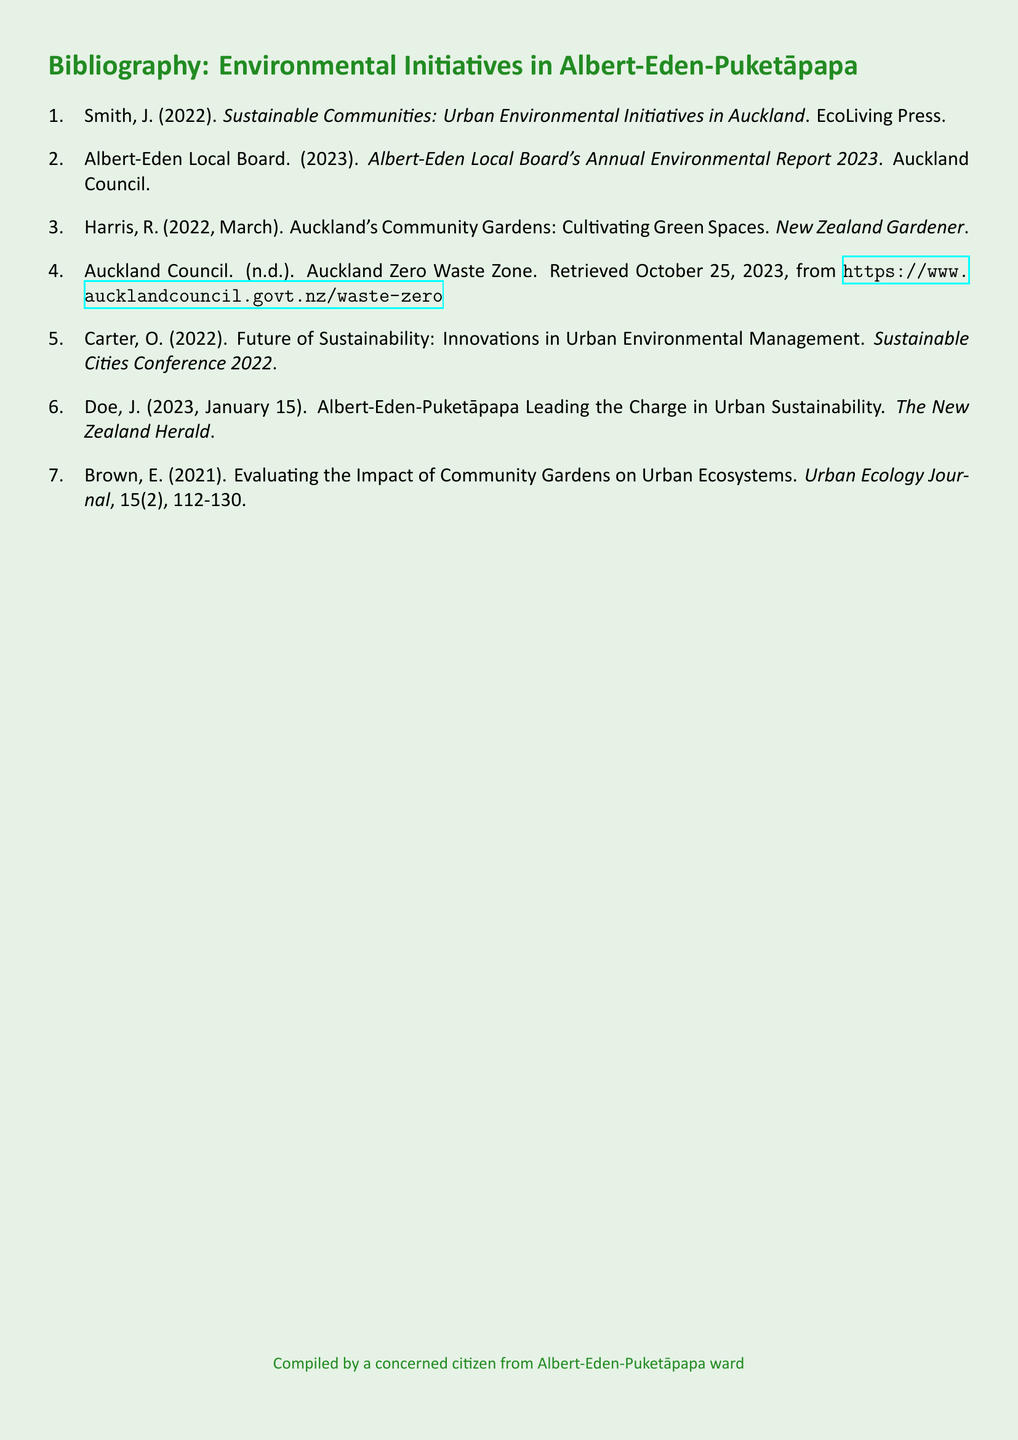What is the title of the document? The title of the document is the heading at the top, clearly stating its purpose.
Answer: Bibliography: Environmental Initiatives in Albert-Eden-Puketāpapa Who authored the environmental report for 2023? The report is published by the Albert-Eden Local Board, which is specified in the citation.
Answer: Albert-Eden Local Board When was the article about community gardens published? The publication date is mentioned directly next to the author's name in the citation.
Answer: March 2022 What organization is associated with the Zero Waste Zone? The organization that provides the information about the Zero Waste Zone is identified in the citation.
Answer: Auckland Council Which author discussed the impact of community gardens? The author focuses on community gardens in their research, and the citation indicates their name.
Answer: Brown, E What is the total number of items in the bibliography? The count of items listed provides a straightforward answer to this question.
Answer: 7 Who is the author of the article titled "Leading the Charge in Urban Sustainability"? The document lists the author for this specific publication clearly.
Answer: Doe, J What publication type is this document? The nature of the document can be identified based on its structure and content type.
Answer: Bibliography 